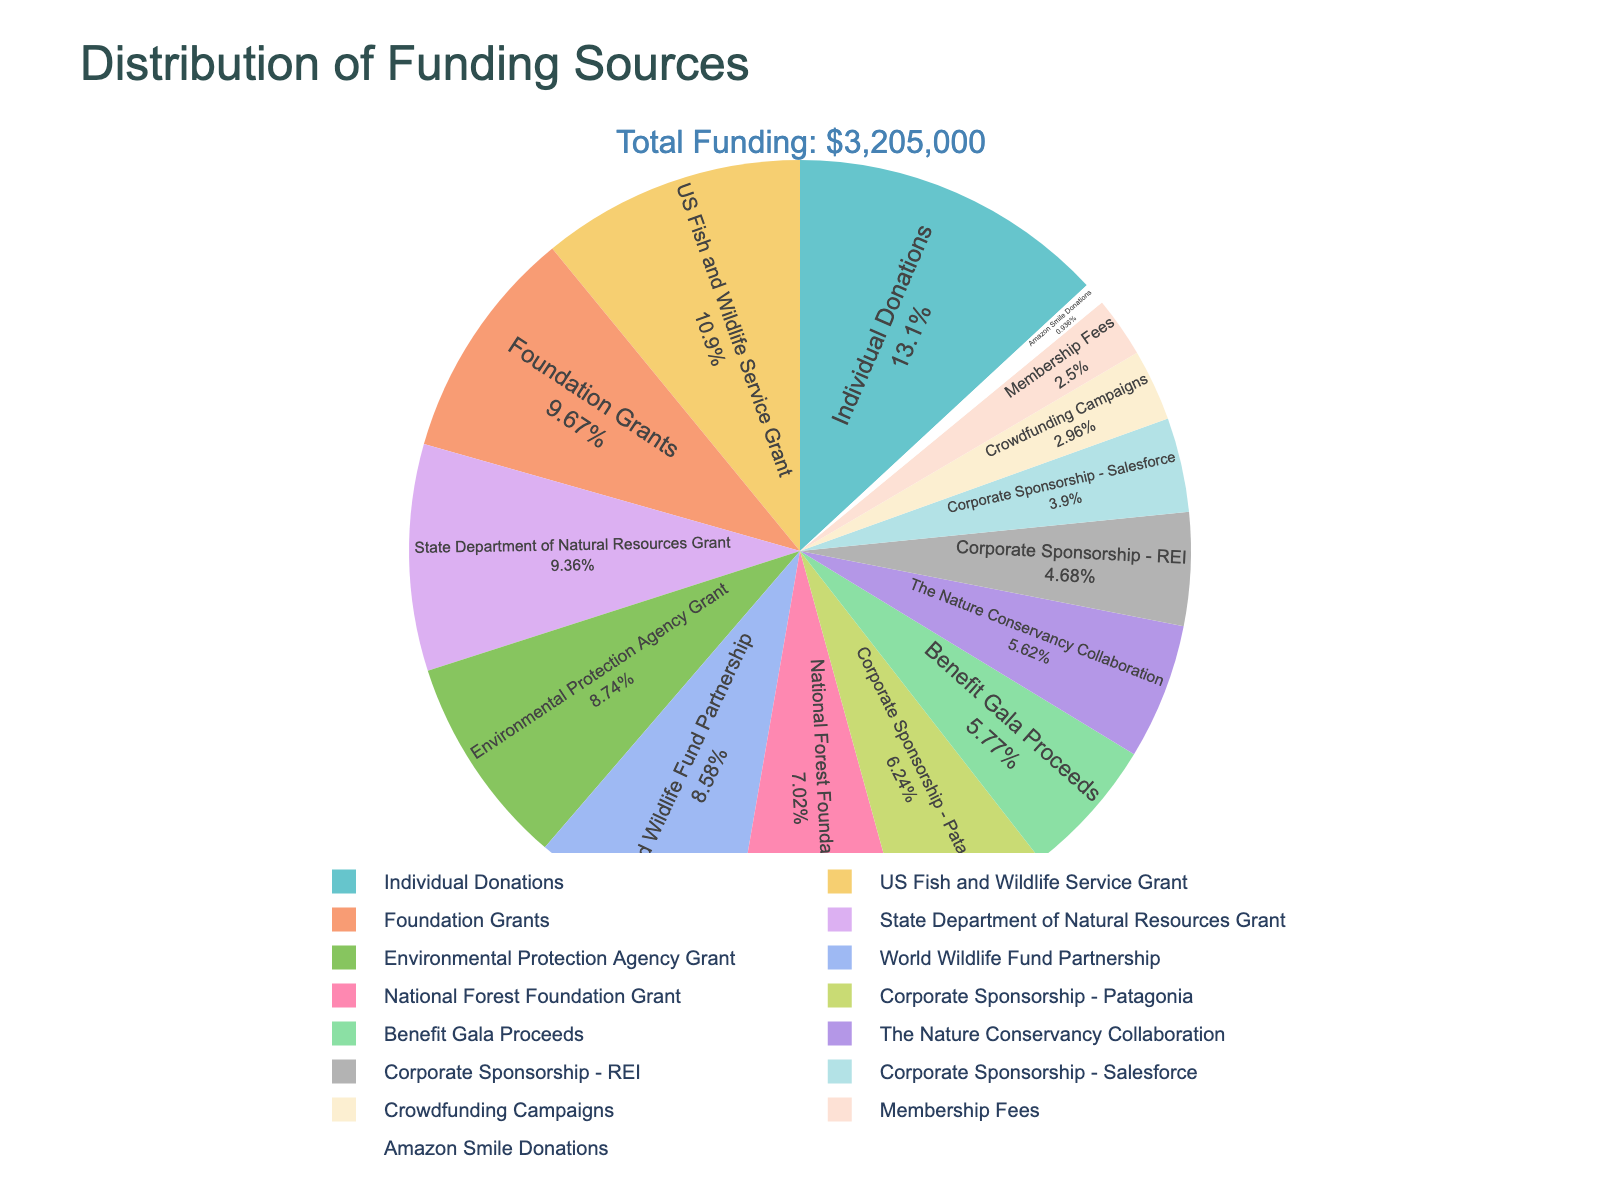Which funding source contributes the most to the NGO's budget? To find this, look at the largest segment in the pie chart. The biggest slice represents the funding source with the highest contribution.
Answer: Individual Donations What is the combined contribution of all corporate sponsorships? Add the amounts from all sections labeled with corporate sponsorships. That includes Patagonia, REI, and Salesforce. Patagonia ($200,000) + REI ($150,000) + Salesforce ($125,000) = $475,000
Answer: $475,000 How does the percentage contribution of the US Fish and Wildlife Service Grant compare to that of Individual Donations? Find the US Fish and Wildlife Service Grant percentage and compare it to the percentage for Individual Donations. Individual Donations have a larger percentage than the US Fish and Wildlife Service Grant.
Answer: Individual Donations is greater What proportion of funding comes from government grants? Calculate the sum of all government grants and divide it by the total funding, then convert it to a percentage. (US Fish and Wildlife Service Grant + State Department of Natural Resources Grant + National Forest Foundation Grant + Environmental Protection Agency Grant) / Total Funding * 100. ($350,000 + $300,000 + $225,000 + $280,000) / $3,275,000 * 100 ≈ 34.81%
Answer: ≈ 34.81% Which funding source has a lower contribution than Crowdfunding Campaigns? Crowdfunding Campaigns contribute $95,000. Look for the funding sources that have smaller contributions in the chart. Amazon Smile Donations at $30,000 is the only one lower.
Answer: Amazon Smile Donations How much greater is the contribution from Foundation Grants compared to Benefit Gala Proceeds? Subtract the amount from Benefit Gala Proceeds from Foundation Grants to find the difference. $310,000 - $185,000 = $125,000
Answer: $125,000 What is the total funding from partnerships and collaborations (excluding corporate sponsorships)? Sum all amounts labeled as partnerships and collaborations. World Wildlife Fund Partnership + The Nature Conservancy Collaboration = $275,000 + $180,000 = $455,000
Answer: $455,000 Is the amount from Membership Fees higher or lower than the funding from Amazon Smile Donations? Compare the amounts in the figure. Membership Fees are $80,000, and Amazon Smile Donations are $30,000. Membership Fees are higher.
Answer: Higher What percentage of the total funding is from Individual Donations? Divide the Individual Donations amount by the total funding amount and multiply by 100. $420,000 / $3,275,000 * 100 ≈ 12.83%
Answer: ≈ 12.83% Are foundation grants or state grants larger in total contribution? Compare the amounts for Foundation Grants and State Department of Natural Resources Grant. Foundation Grants are $310,000, which is greater than the State Department of Natural Resources Grant at $300,000.
Answer: Foundation Grants 